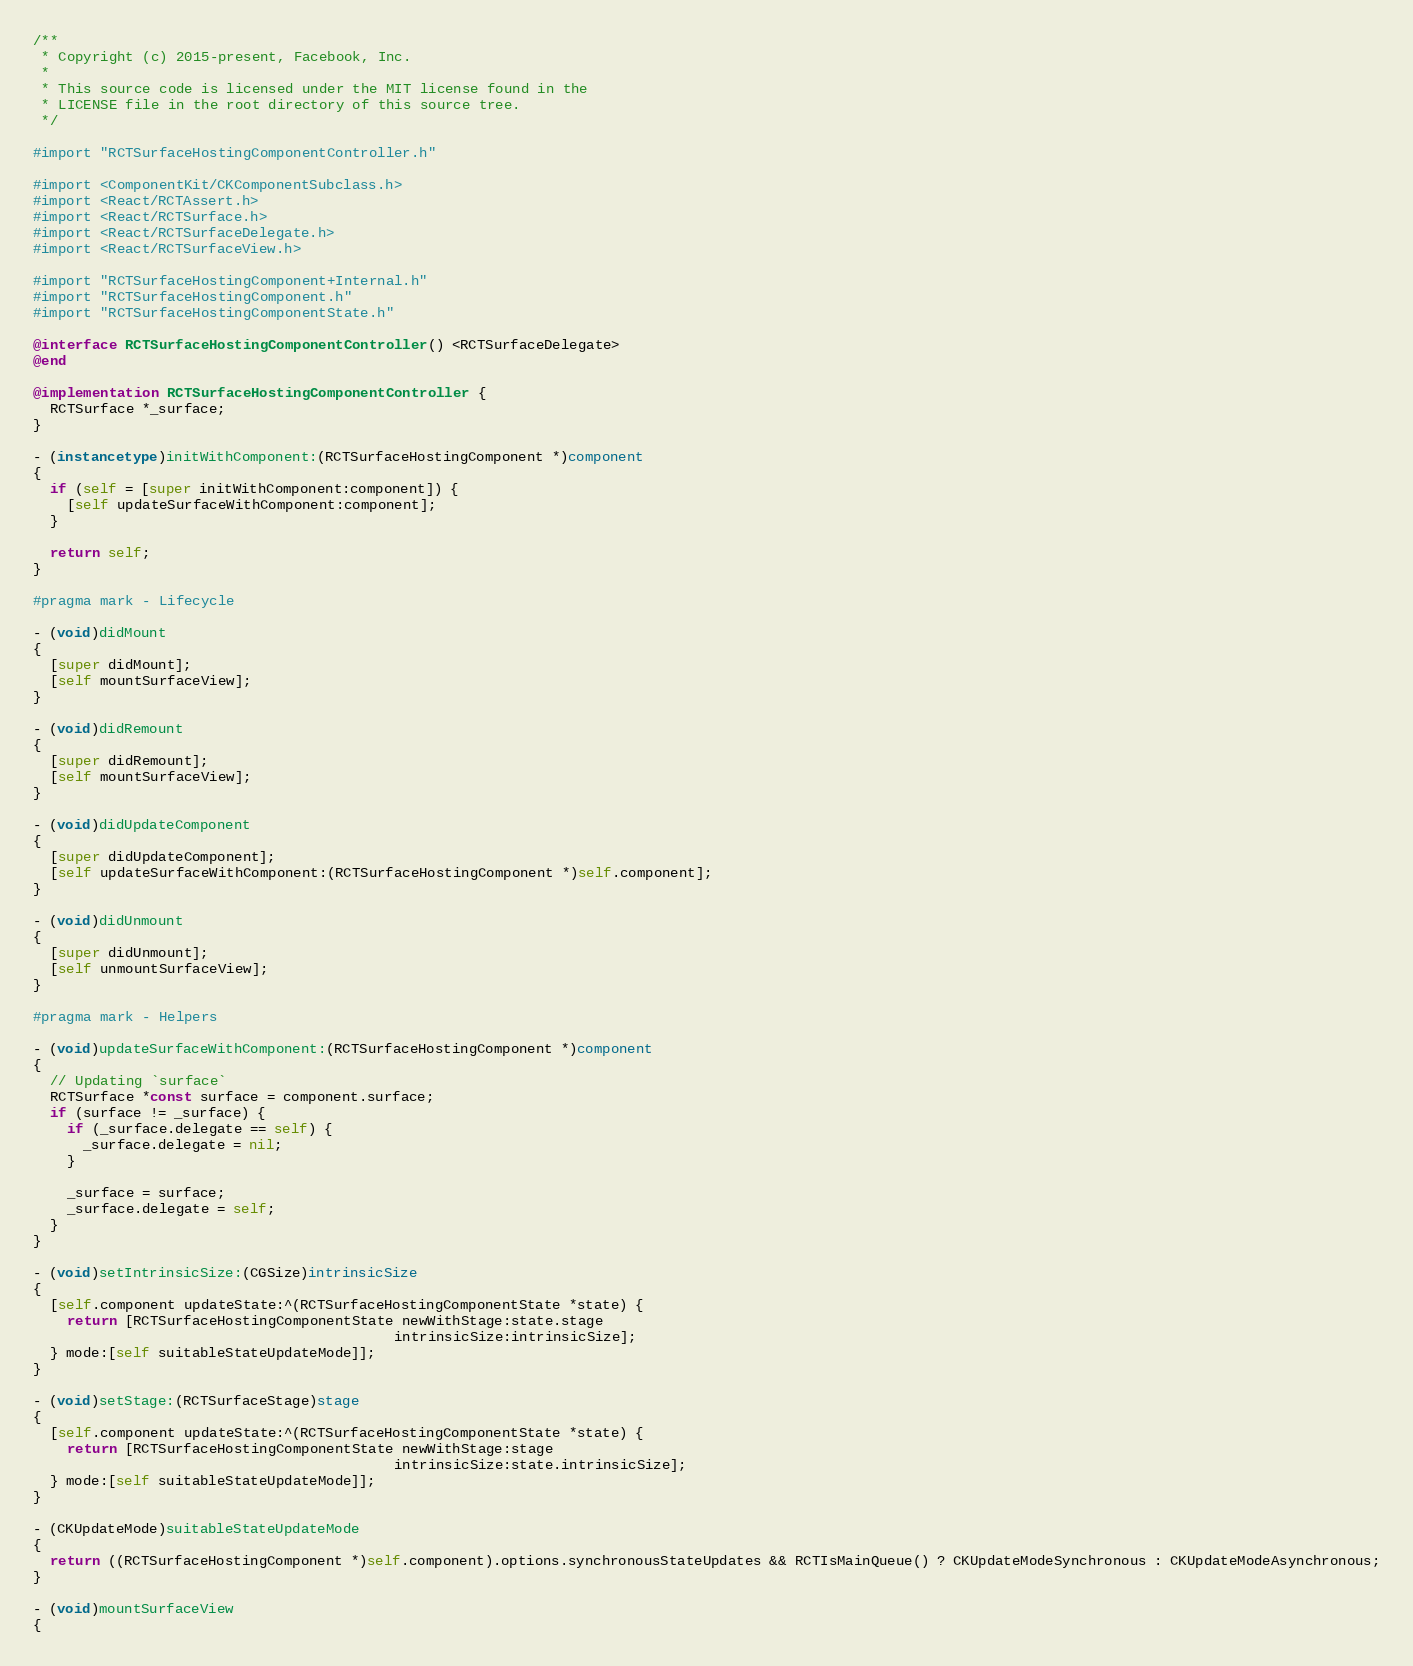Convert code to text. <code><loc_0><loc_0><loc_500><loc_500><_ObjectiveC_>/**
 * Copyright (c) 2015-present, Facebook, Inc.
 *
 * This source code is licensed under the MIT license found in the
 * LICENSE file in the root directory of this source tree.
 */

#import "RCTSurfaceHostingComponentController.h"

#import <ComponentKit/CKComponentSubclass.h>
#import <React/RCTAssert.h>
#import <React/RCTSurface.h>
#import <React/RCTSurfaceDelegate.h>
#import <React/RCTSurfaceView.h>

#import "RCTSurfaceHostingComponent+Internal.h"
#import "RCTSurfaceHostingComponent.h"
#import "RCTSurfaceHostingComponentState.h"

@interface RCTSurfaceHostingComponentController() <RCTSurfaceDelegate>
@end

@implementation RCTSurfaceHostingComponentController {
  RCTSurface *_surface;
}

- (instancetype)initWithComponent:(RCTSurfaceHostingComponent *)component
{
  if (self = [super initWithComponent:component]) {
    [self updateSurfaceWithComponent:component];
  }

  return self;
}

#pragma mark - Lifecycle

- (void)didMount
{
  [super didMount];
  [self mountSurfaceView];
}

- (void)didRemount
{
  [super didRemount];
  [self mountSurfaceView];
}

- (void)didUpdateComponent
{
  [super didUpdateComponent];
  [self updateSurfaceWithComponent:(RCTSurfaceHostingComponent *)self.component];
}

- (void)didUnmount
{
  [super didUnmount];
  [self unmountSurfaceView];
}

#pragma mark - Helpers

- (void)updateSurfaceWithComponent:(RCTSurfaceHostingComponent *)component
{
  // Updating `surface`
  RCTSurface *const surface = component.surface;
  if (surface != _surface) {
    if (_surface.delegate == self) {
      _surface.delegate = nil;
    }

    _surface = surface;
    _surface.delegate = self;
  }
}

- (void)setIntrinsicSize:(CGSize)intrinsicSize
{
  [self.component updateState:^(RCTSurfaceHostingComponentState *state) {
    return [RCTSurfaceHostingComponentState newWithStage:state.stage
                                           intrinsicSize:intrinsicSize];
  } mode:[self suitableStateUpdateMode]];
}

- (void)setStage:(RCTSurfaceStage)stage
{
  [self.component updateState:^(RCTSurfaceHostingComponentState *state) {
    return [RCTSurfaceHostingComponentState newWithStage:stage
                                           intrinsicSize:state.intrinsicSize];
  } mode:[self suitableStateUpdateMode]];
}

- (CKUpdateMode)suitableStateUpdateMode
{
  return ((RCTSurfaceHostingComponent *)self.component).options.synchronousStateUpdates && RCTIsMainQueue() ? CKUpdateModeSynchronous : CKUpdateModeAsynchronous;
}

- (void)mountSurfaceView
{</code> 